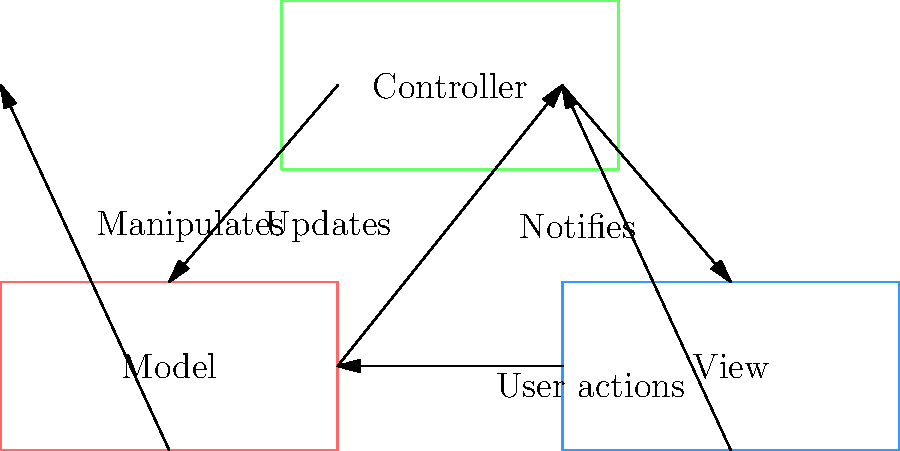In the Backbone.js MVC architecture flowchart, which component directly updates the Model? To answer this question, let's break down the Backbone.js MVC (Model-View-Controller) architecture as shown in the flowchart:

1. The flowchart shows three main components: Model (red), View (blue), and Controller (green).

2. We can see arrows connecting these components, representing the flow of data and actions:

   a) From Controller to Model: This arrow is labeled "Manipulates".
   b) From Model to View: This arrow is labeled "Updates".
   c) From View to Controller: This arrow is labeled "User actions".
   d) From Controller to View: This arrow is unlabeled but implies the Controller updating the View.

3. The key relationship we're looking for is which component directly updates the Model.

4. Following the arrows, we can see that the only component with a direct arrow to the Model is the Controller, labeled "Manipulates".

5. This indicates that in Backbone.js, the Controller is responsible for directly updating the Model based on user actions or other events.

Therefore, the component that directly updates the Model in the Backbone.js MVC architecture is the Controller.
Answer: Controller 